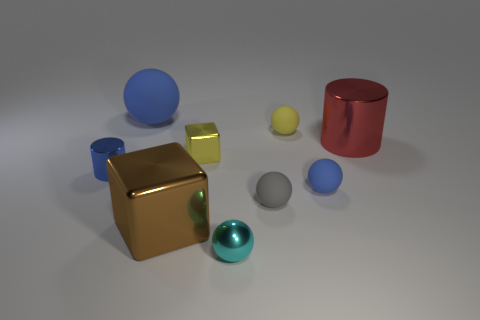What is the material of the brown object?
Your answer should be very brief. Metal. Is the gray object the same shape as the red metallic object?
Give a very brief answer. No. Are there any yellow objects made of the same material as the small blue ball?
Offer a very short reply. Yes. What is the color of the sphere that is behind the yellow cube and to the right of the small yellow shiny object?
Your answer should be very brief. Yellow. There is a tiny blue object that is right of the tiny yellow cube; what is it made of?
Give a very brief answer. Rubber. Are there any blue matte objects that have the same shape as the brown thing?
Your response must be concise. No. How many other objects are the same shape as the large brown object?
Give a very brief answer. 1. There is a large brown shiny object; does it have the same shape as the metal object right of the shiny ball?
Your response must be concise. No. There is a small cyan object that is the same shape as the yellow matte thing; what is its material?
Provide a short and direct response. Metal. How many small objects are brown cubes or green metal blocks?
Offer a very short reply. 0. 